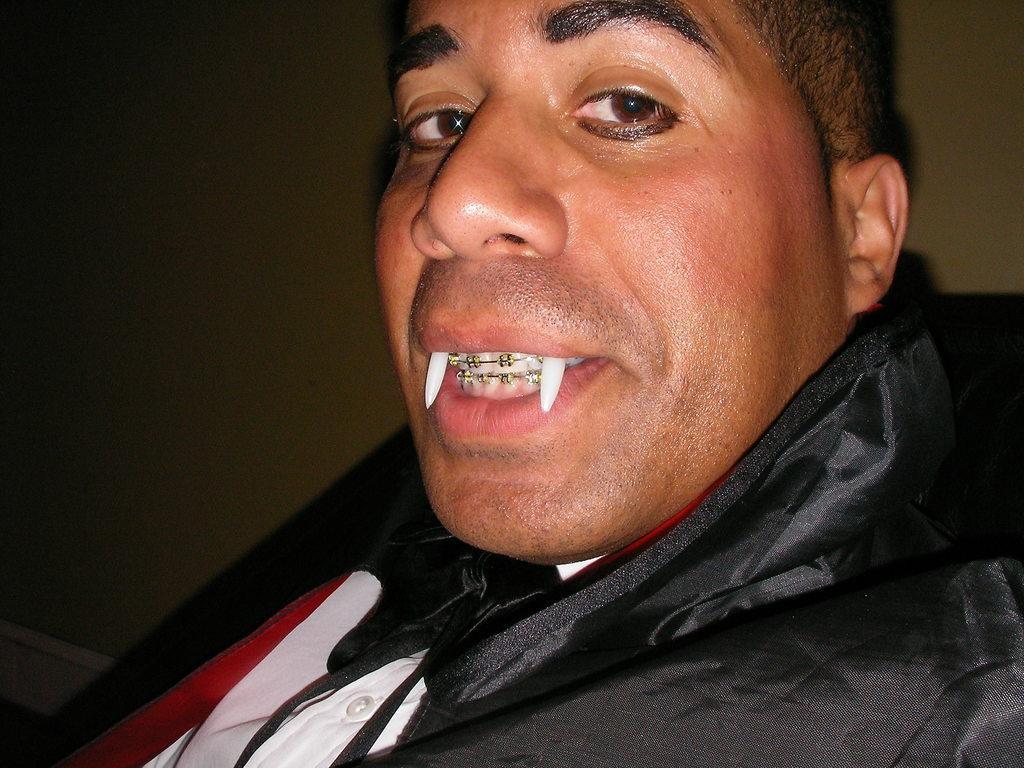Can you describe this image briefly? This image is taken indoors. In the background there is a wall. On the right side of the image there is a man. He is with dental braces on the teeth and there are two devil teeth. 